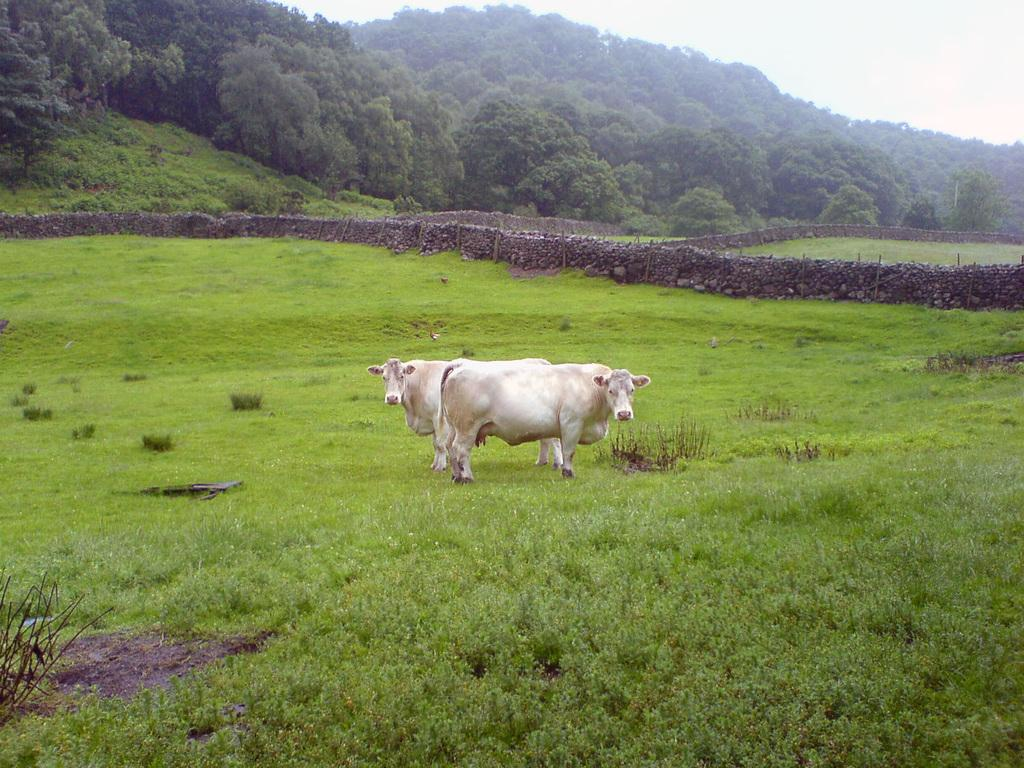What animals can be seen on the grass in the image? There are two cows on the grass in the image. What type of structures are present in the image? There are compound walls in the image. What type of vegetation can be seen in the image? There are trees and plants in the image. What is visible in the background of the image? The sky is visible in the background of the image. What is the relation between the cows and the trees in the image? There is no specific relation between the cows and the trees mentioned in the image; they are simply two separate elements in the scene. 